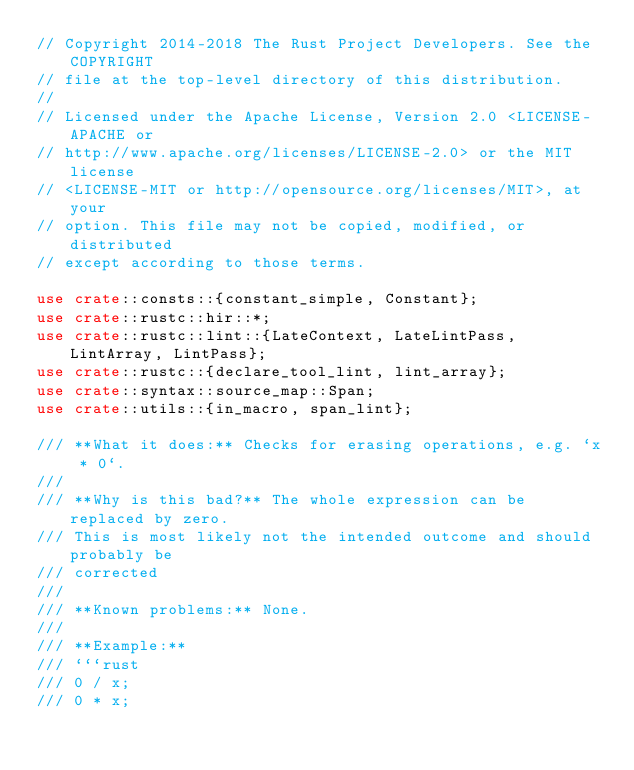Convert code to text. <code><loc_0><loc_0><loc_500><loc_500><_Rust_>// Copyright 2014-2018 The Rust Project Developers. See the COPYRIGHT
// file at the top-level directory of this distribution.
//
// Licensed under the Apache License, Version 2.0 <LICENSE-APACHE or
// http://www.apache.org/licenses/LICENSE-2.0> or the MIT license
// <LICENSE-MIT or http://opensource.org/licenses/MIT>, at your
// option. This file may not be copied, modified, or distributed
// except according to those terms.

use crate::consts::{constant_simple, Constant};
use crate::rustc::hir::*;
use crate::rustc::lint::{LateContext, LateLintPass, LintArray, LintPass};
use crate::rustc::{declare_tool_lint, lint_array};
use crate::syntax::source_map::Span;
use crate::utils::{in_macro, span_lint};

/// **What it does:** Checks for erasing operations, e.g. `x * 0`.
///
/// **Why is this bad?** The whole expression can be replaced by zero.
/// This is most likely not the intended outcome and should probably be
/// corrected
///
/// **Known problems:** None.
///
/// **Example:**
/// ```rust
/// 0 / x;
/// 0 * x;</code> 